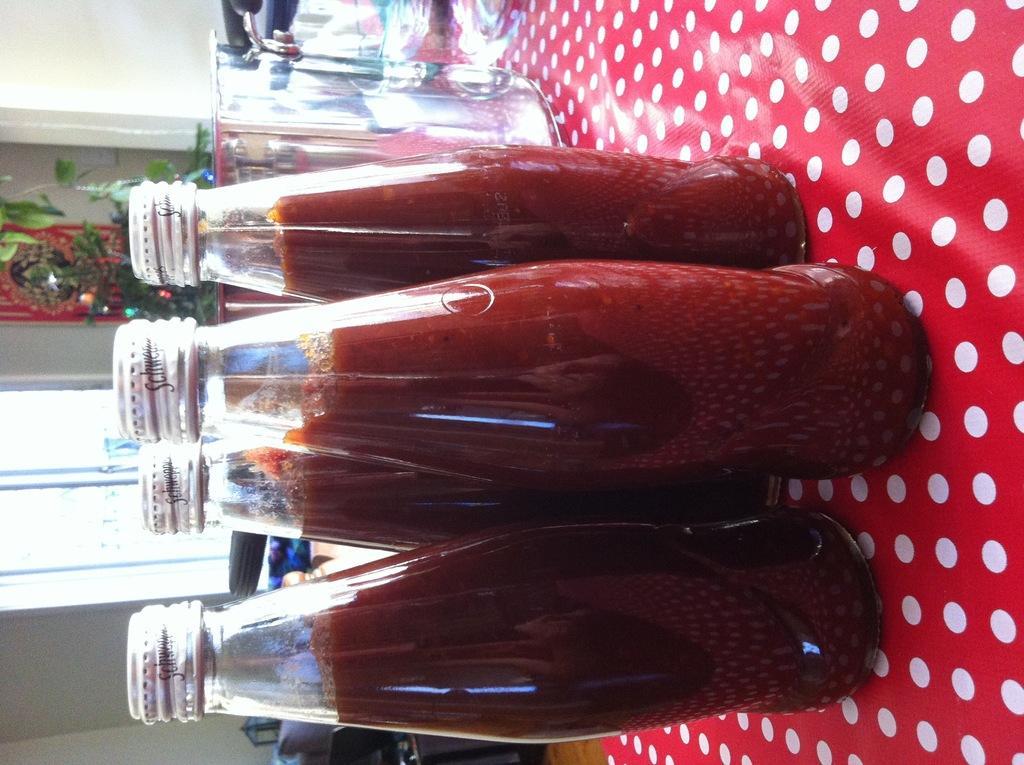In one or two sentences, can you explain what this image depicts? There are bottles on the table. This is glass. On the background there is a wall and this is window. There is a plant. 